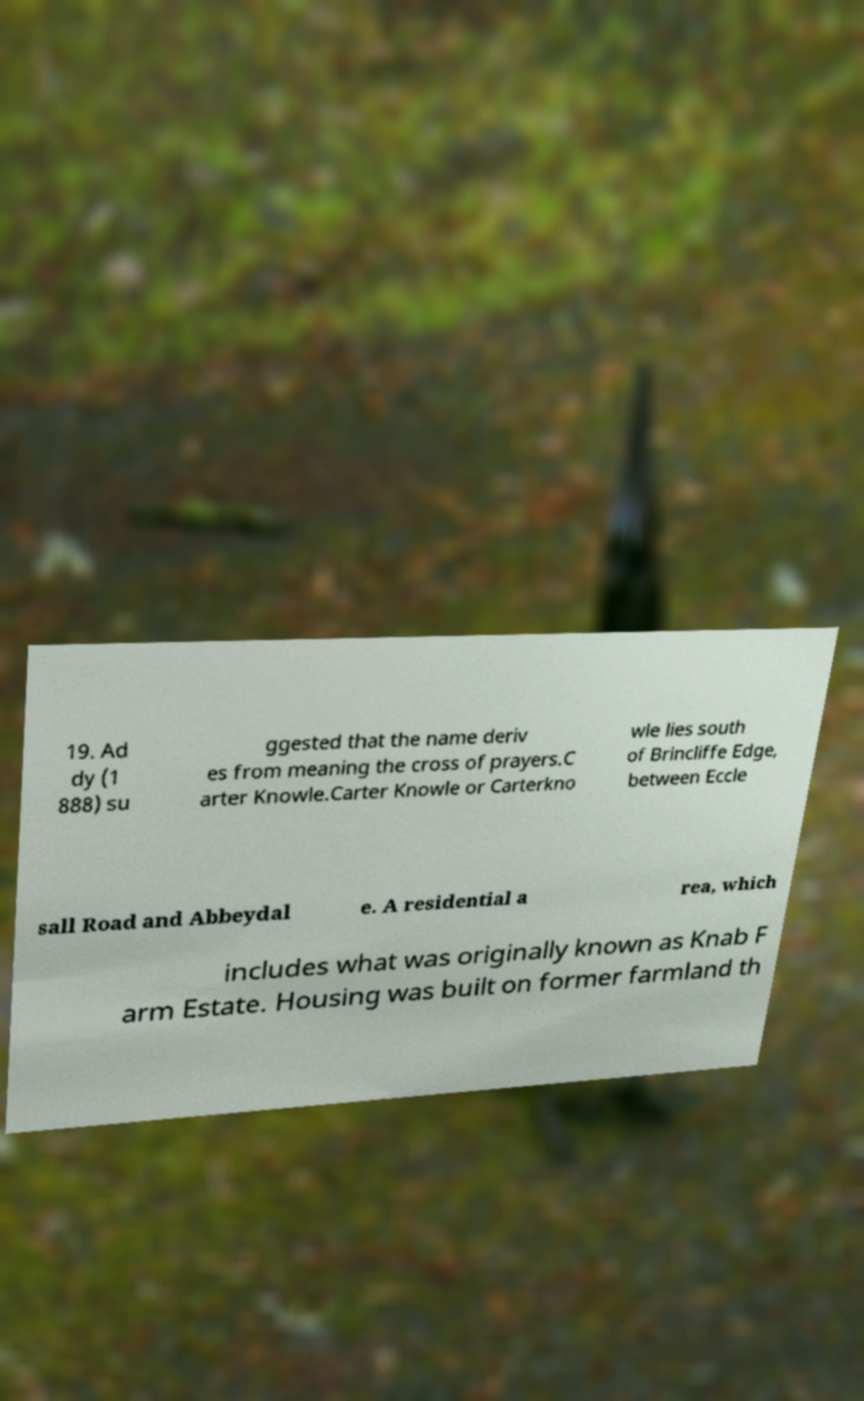Can you accurately transcribe the text from the provided image for me? 19. Ad dy (1 888) su ggested that the name deriv es from meaning the cross of prayers.C arter Knowle.Carter Knowle or Carterkno wle lies south of Brincliffe Edge, between Eccle sall Road and Abbeydal e. A residential a rea, which includes what was originally known as Knab F arm Estate. Housing was built on former farmland th 